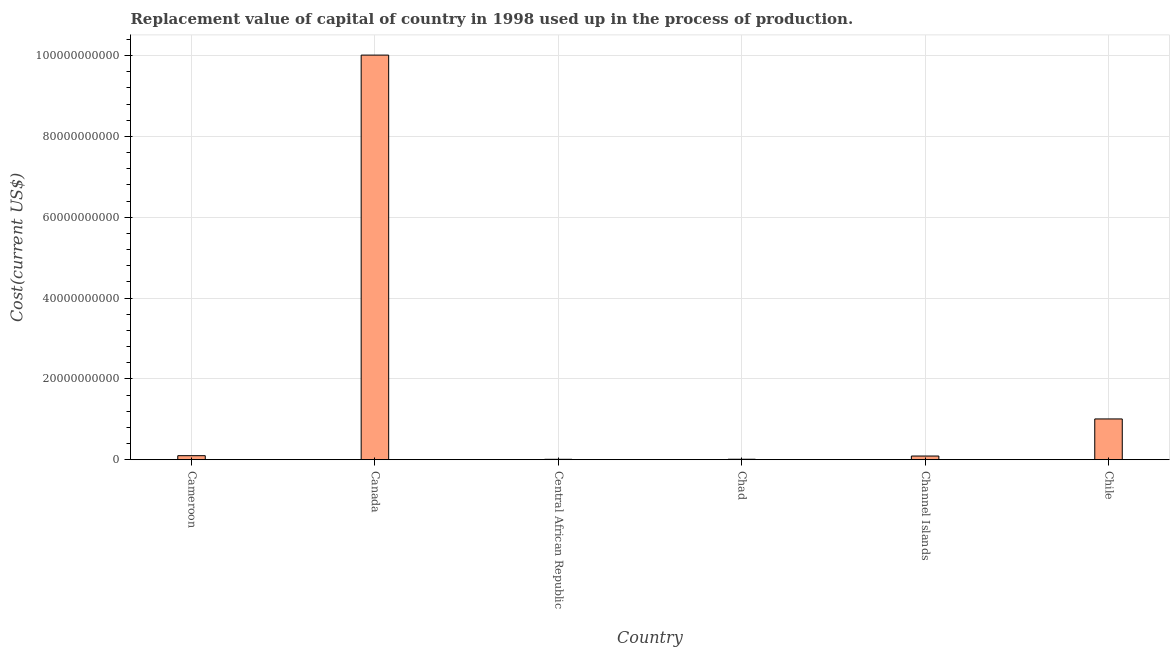What is the title of the graph?
Keep it short and to the point. Replacement value of capital of country in 1998 used up in the process of production. What is the label or title of the X-axis?
Keep it short and to the point. Country. What is the label or title of the Y-axis?
Provide a succinct answer. Cost(current US$). What is the consumption of fixed capital in Canada?
Make the answer very short. 1.00e+11. Across all countries, what is the maximum consumption of fixed capital?
Give a very brief answer. 1.00e+11. Across all countries, what is the minimum consumption of fixed capital?
Keep it short and to the point. 9.70e+07. In which country was the consumption of fixed capital minimum?
Keep it short and to the point. Central African Republic. What is the sum of the consumption of fixed capital?
Ensure brevity in your answer.  1.12e+11. What is the difference between the consumption of fixed capital in Cameroon and Chad?
Provide a succinct answer. 8.82e+08. What is the average consumption of fixed capital per country?
Offer a terse response. 1.87e+1. What is the median consumption of fixed capital?
Your answer should be compact. 9.50e+08. In how many countries, is the consumption of fixed capital greater than 88000000000 US$?
Provide a short and direct response. 1. What is the ratio of the consumption of fixed capital in Cameroon to that in Channel Islands?
Offer a terse response. 1.1. What is the difference between the highest and the second highest consumption of fixed capital?
Keep it short and to the point. 9.00e+1. Is the sum of the consumption of fixed capital in Central African Republic and Chad greater than the maximum consumption of fixed capital across all countries?
Provide a short and direct response. No. What is the difference between the highest and the lowest consumption of fixed capital?
Ensure brevity in your answer.  1.00e+11. In how many countries, is the consumption of fixed capital greater than the average consumption of fixed capital taken over all countries?
Offer a very short reply. 1. How many countries are there in the graph?
Make the answer very short. 6. What is the difference between two consecutive major ticks on the Y-axis?
Make the answer very short. 2.00e+1. What is the Cost(current US$) of Cameroon?
Offer a very short reply. 9.94e+08. What is the Cost(current US$) in Canada?
Make the answer very short. 1.00e+11. What is the Cost(current US$) in Central African Republic?
Your answer should be very brief. 9.70e+07. What is the Cost(current US$) in Chad?
Keep it short and to the point. 1.13e+08. What is the Cost(current US$) in Channel Islands?
Give a very brief answer. 9.05e+08. What is the Cost(current US$) of Chile?
Provide a succinct answer. 1.01e+1. What is the difference between the Cost(current US$) in Cameroon and Canada?
Your answer should be very brief. -9.91e+1. What is the difference between the Cost(current US$) in Cameroon and Central African Republic?
Give a very brief answer. 8.97e+08. What is the difference between the Cost(current US$) in Cameroon and Chad?
Offer a very short reply. 8.82e+08. What is the difference between the Cost(current US$) in Cameroon and Channel Islands?
Give a very brief answer. 8.94e+07. What is the difference between the Cost(current US$) in Cameroon and Chile?
Keep it short and to the point. -9.09e+09. What is the difference between the Cost(current US$) in Canada and Central African Republic?
Provide a succinct answer. 1.00e+11. What is the difference between the Cost(current US$) in Canada and Chad?
Your answer should be compact. 1.00e+11. What is the difference between the Cost(current US$) in Canada and Channel Islands?
Give a very brief answer. 9.92e+1. What is the difference between the Cost(current US$) in Canada and Chile?
Your answer should be compact. 9.00e+1. What is the difference between the Cost(current US$) in Central African Republic and Chad?
Your answer should be very brief. -1.57e+07. What is the difference between the Cost(current US$) in Central African Republic and Channel Islands?
Make the answer very short. -8.08e+08. What is the difference between the Cost(current US$) in Central African Republic and Chile?
Ensure brevity in your answer.  -9.99e+09. What is the difference between the Cost(current US$) in Chad and Channel Islands?
Your answer should be compact. -7.92e+08. What is the difference between the Cost(current US$) in Chad and Chile?
Offer a very short reply. -9.97e+09. What is the difference between the Cost(current US$) in Channel Islands and Chile?
Offer a terse response. -9.18e+09. What is the ratio of the Cost(current US$) in Cameroon to that in Canada?
Offer a very short reply. 0.01. What is the ratio of the Cost(current US$) in Cameroon to that in Central African Republic?
Provide a succinct answer. 10.25. What is the ratio of the Cost(current US$) in Cameroon to that in Chad?
Your answer should be compact. 8.82. What is the ratio of the Cost(current US$) in Cameroon to that in Channel Islands?
Give a very brief answer. 1.1. What is the ratio of the Cost(current US$) in Cameroon to that in Chile?
Your response must be concise. 0.1. What is the ratio of the Cost(current US$) in Canada to that in Central African Republic?
Your answer should be very brief. 1031.76. What is the ratio of the Cost(current US$) in Canada to that in Chad?
Offer a very short reply. 887.84. What is the ratio of the Cost(current US$) in Canada to that in Channel Islands?
Ensure brevity in your answer.  110.61. What is the ratio of the Cost(current US$) in Canada to that in Chile?
Offer a terse response. 9.93. What is the ratio of the Cost(current US$) in Central African Republic to that in Chad?
Provide a short and direct response. 0.86. What is the ratio of the Cost(current US$) in Central African Republic to that in Channel Islands?
Your response must be concise. 0.11. What is the ratio of the Cost(current US$) in Central African Republic to that in Chile?
Provide a succinct answer. 0.01. What is the ratio of the Cost(current US$) in Chad to that in Chile?
Make the answer very short. 0.01. What is the ratio of the Cost(current US$) in Channel Islands to that in Chile?
Provide a succinct answer. 0.09. 